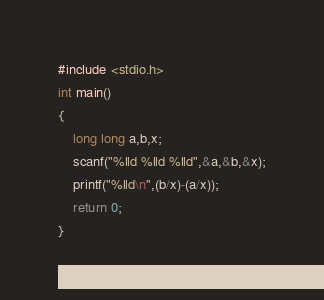<code> <loc_0><loc_0><loc_500><loc_500><_C_>#include <stdio.h>
int main()
{
    long long a,b,x;
    scanf("%lld %lld %lld",&a,&b,&x);
    printf("%lld\n",(b/x)-(a/x));
    return 0;
}
</code> 